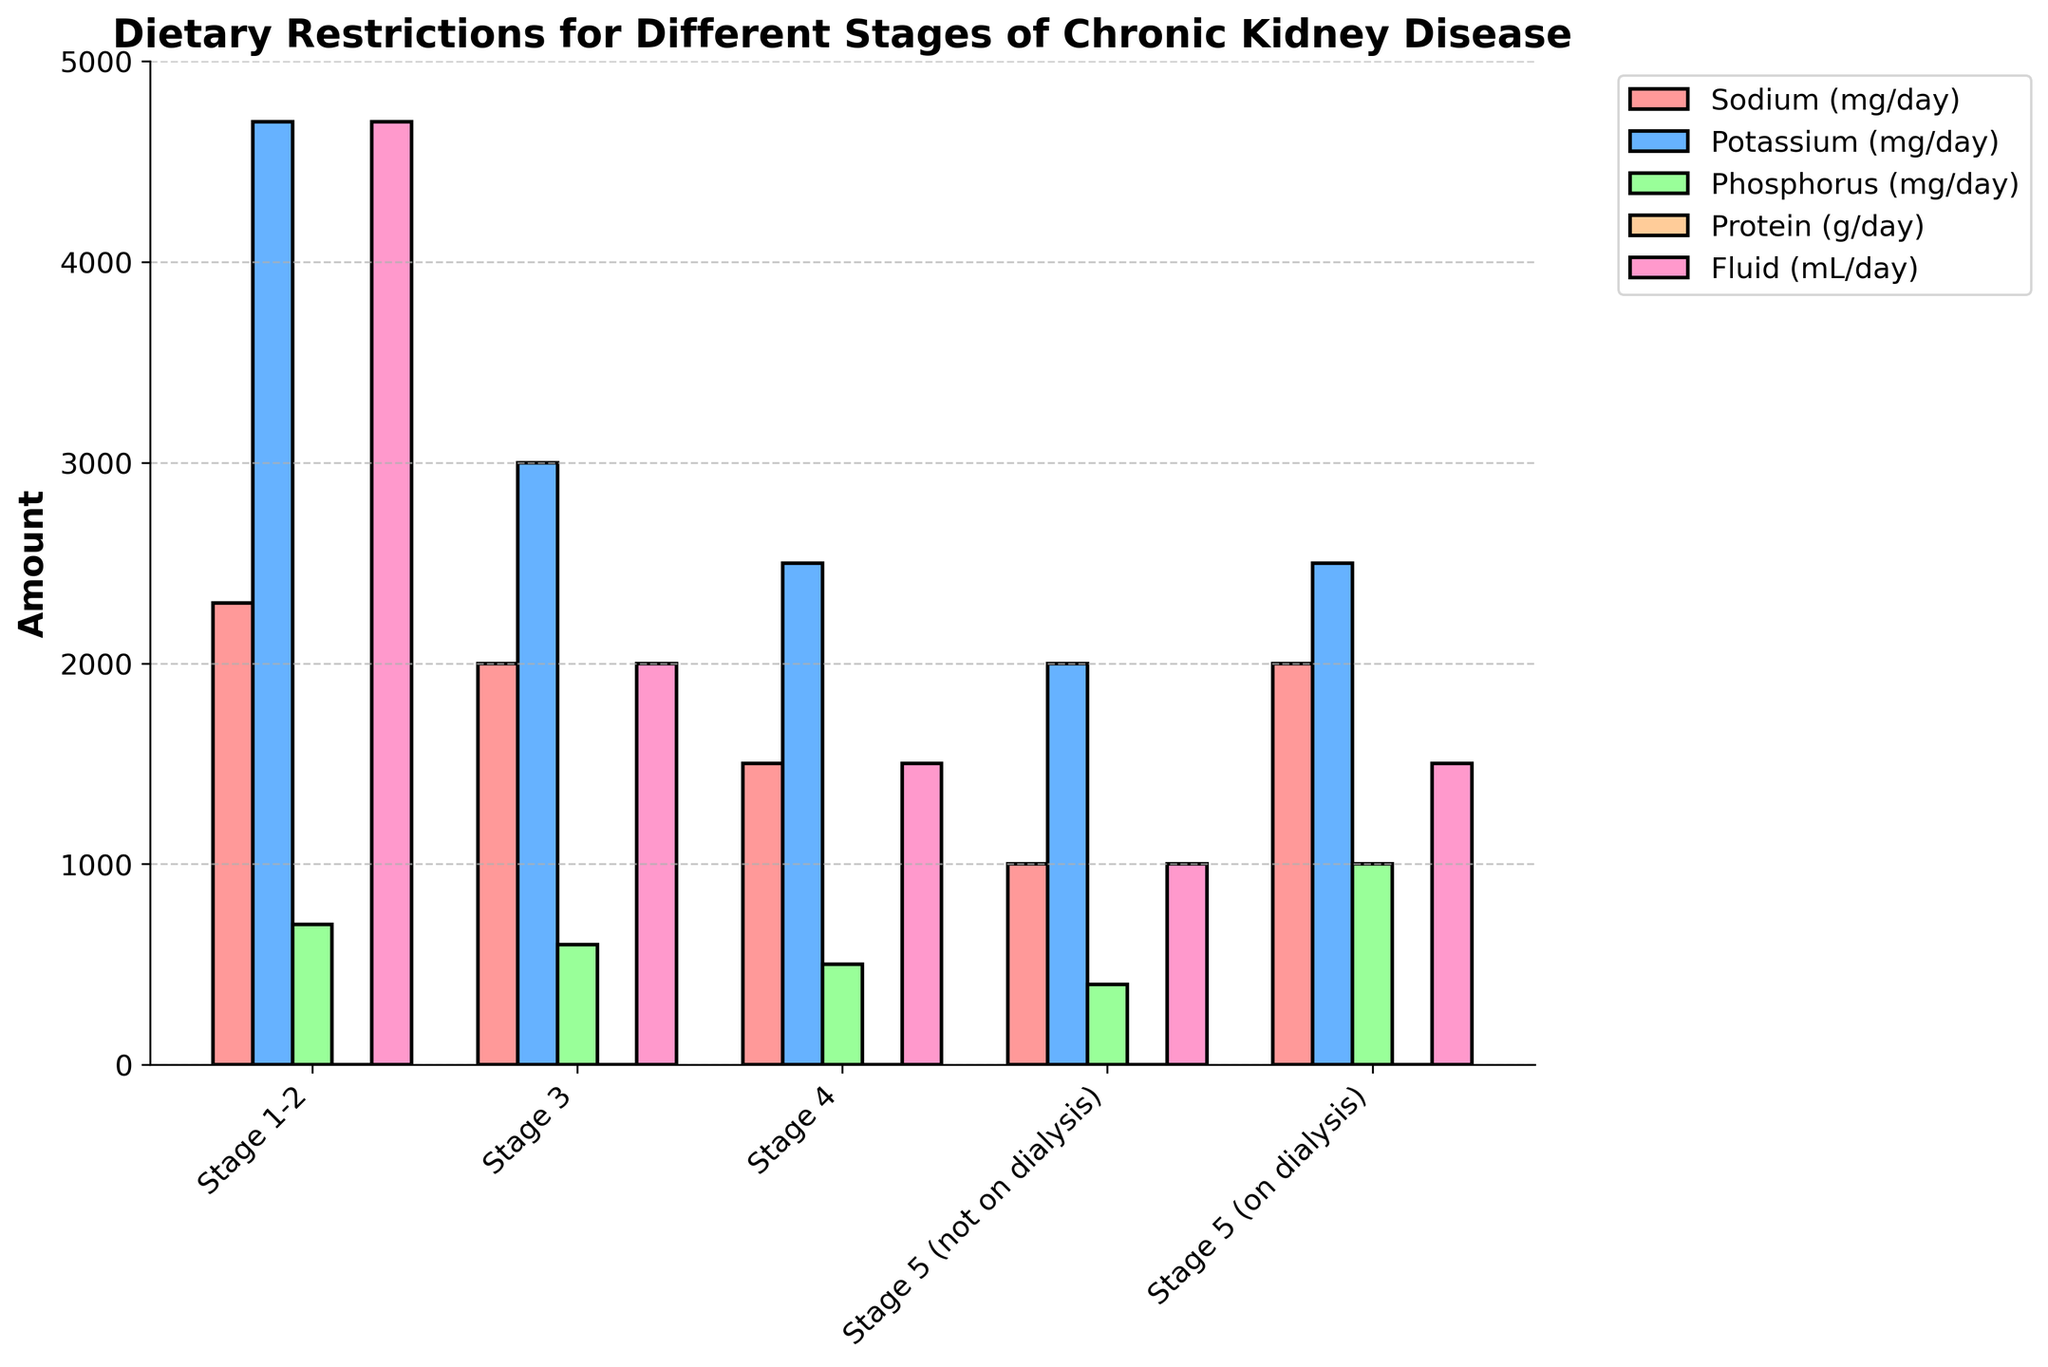What stage has the highest sodium restriction? The height of the bars represents the Sodium (mg/day) for each stage. The tallest bar in the Sodium category is for Stage 1-2.
Answer: Stage 1-2 How does the potassium restriction change from Stage 3 to Stage 5 (not on dialysis)? Compare the heights of the Potassium (mg/day) bars for Stage 3 and Stage 5 (not on dialysis). Stage 3 has a bar height of 3000 mg/day, and Stage 5 (not on dialysis) has a bar height of 2000 mg/day.
Answer: It decreases by 1000 mg/day Which stage has the greatest phosphorus restriction, and how much is restricted? Look for the shortest bar in the Phosphorus category. The shortest bar is for Stage 5 (not on dialysis), which is 400 mg/day.
Answer: Stage 5 (not on dialysis), 400 mg/day What is the difference in fluid restriction between Stage 4 and Stage 5 (on dialysis)? Compare the heights of the Fluid (mL/day) bars for Stage 4 and Stage 5 (on dialysis). Stage 4 has 1500 mL/day, and Stage 5 (on dialysis) also has 1500 mL/day, so the difference is 0.
Answer: 0 mL/day What is the average protein restriction for all stages? Sum the Protein (g/day) values for all stages and divide by the number of stages: (0.8+0.6+0.6+0.6+1.2)/5 = 3.8/5.
Answer: 0.76 g/day Which nutrient has the most consistent restriction across all stages, based on visual inspection? By observing the uniform heights of the bars across all stages, Protein (g/day) appears to have the most consistent values, ranging from 0.6 to 1.2 g/day.
Answer: Protein (g/day) How does the phosphorus restriction in Stage 1-2 compare to Stage 3? Look at the heights of the Phosphorus (mg/day) bars. Stage 1-2 has 700 mg/day, and Stage 3 has 600 mg/day.
Answer: Stage 1-2 is 100 mg/day higher than Stage 3 What is the combined sodium and potassium restriction for Stage 4? Add the Sodium (mg/day) and Potassium (mg/day) values: 1500 + 2500.
Answer: 4000 mg/day Which stage has the least fluid restriction and how much fluid is allowed? Look for the tallest bar in the Fluid (mL/day) category. "No restriction" implies the tallest bar for Stage 1-2.
Answer: Stage 1-2, No restriction What is the difference in potassium restriction between Stage 4 and Stage 5 (on dialysis)? Compare the heights of the Potassium (mg/day) bars for Stage 4 and Stage 5 (on dialysis). Stage 4 has 2500 mg/day and Stage 5 (on dialysis) has 2500 mg/day.
Answer: 0 mg/day 